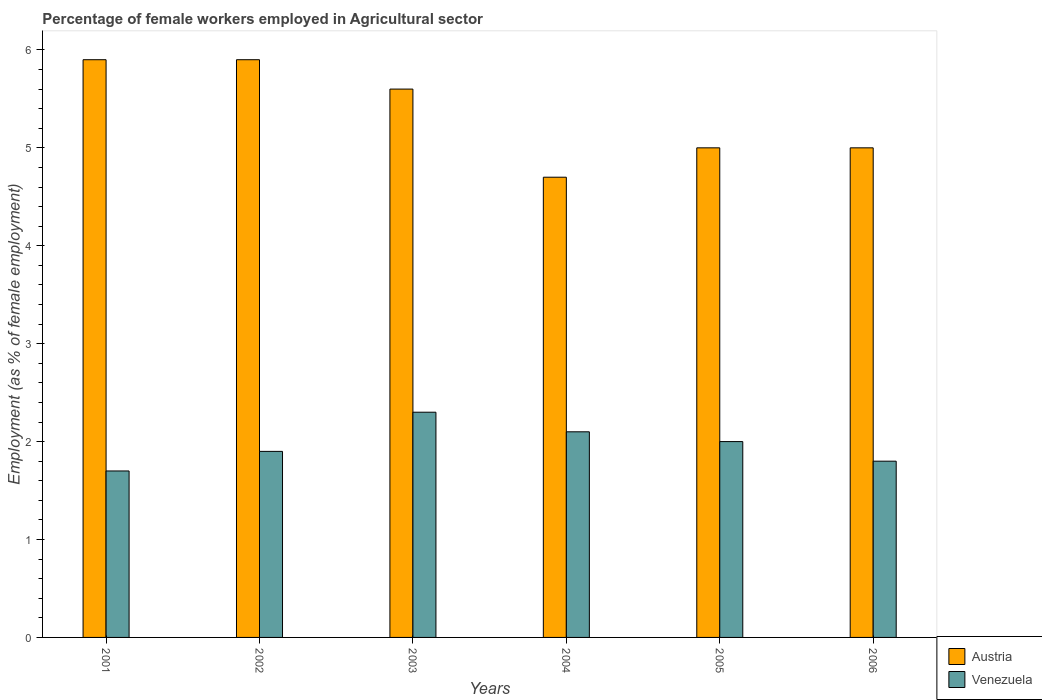How many different coloured bars are there?
Ensure brevity in your answer.  2. Are the number of bars per tick equal to the number of legend labels?
Your response must be concise. Yes. How many bars are there on the 3rd tick from the left?
Your response must be concise. 2. What is the label of the 1st group of bars from the left?
Your answer should be very brief. 2001. In how many cases, is the number of bars for a given year not equal to the number of legend labels?
Your answer should be compact. 0. What is the percentage of females employed in Agricultural sector in Austria in 2005?
Your answer should be very brief. 5. Across all years, what is the maximum percentage of females employed in Agricultural sector in Austria?
Offer a very short reply. 5.9. Across all years, what is the minimum percentage of females employed in Agricultural sector in Austria?
Your response must be concise. 4.7. In which year was the percentage of females employed in Agricultural sector in Austria maximum?
Offer a very short reply. 2001. What is the total percentage of females employed in Agricultural sector in Austria in the graph?
Give a very brief answer. 32.1. What is the difference between the percentage of females employed in Agricultural sector in Venezuela in 2001 and that in 2003?
Give a very brief answer. -0.6. What is the difference between the percentage of females employed in Agricultural sector in Austria in 2003 and the percentage of females employed in Agricultural sector in Venezuela in 2004?
Your answer should be compact. 3.5. What is the average percentage of females employed in Agricultural sector in Austria per year?
Your response must be concise. 5.35. In the year 2005, what is the difference between the percentage of females employed in Agricultural sector in Austria and percentage of females employed in Agricultural sector in Venezuela?
Provide a succinct answer. 3. In how many years, is the percentage of females employed in Agricultural sector in Venezuela greater than 2.2 %?
Offer a terse response. 1. What is the ratio of the percentage of females employed in Agricultural sector in Venezuela in 2004 to that in 2005?
Provide a short and direct response. 1.05. Is the percentage of females employed in Agricultural sector in Austria in 2001 less than that in 2006?
Keep it short and to the point. No. Is the difference between the percentage of females employed in Agricultural sector in Austria in 2005 and 2006 greater than the difference between the percentage of females employed in Agricultural sector in Venezuela in 2005 and 2006?
Provide a short and direct response. No. What is the difference between the highest and the second highest percentage of females employed in Agricultural sector in Austria?
Keep it short and to the point. 0. What is the difference between the highest and the lowest percentage of females employed in Agricultural sector in Austria?
Provide a short and direct response. 1.2. In how many years, is the percentage of females employed in Agricultural sector in Venezuela greater than the average percentage of females employed in Agricultural sector in Venezuela taken over all years?
Your answer should be compact. 3. What does the 1st bar from the left in 2002 represents?
Make the answer very short. Austria. What does the 2nd bar from the right in 2005 represents?
Ensure brevity in your answer.  Austria. Are all the bars in the graph horizontal?
Make the answer very short. No. What is the difference between two consecutive major ticks on the Y-axis?
Your answer should be compact. 1. Are the values on the major ticks of Y-axis written in scientific E-notation?
Provide a short and direct response. No. Does the graph contain any zero values?
Make the answer very short. No. How many legend labels are there?
Ensure brevity in your answer.  2. How are the legend labels stacked?
Your answer should be compact. Vertical. What is the title of the graph?
Your answer should be compact. Percentage of female workers employed in Agricultural sector. Does "Burundi" appear as one of the legend labels in the graph?
Offer a terse response. No. What is the label or title of the X-axis?
Provide a short and direct response. Years. What is the label or title of the Y-axis?
Offer a very short reply. Employment (as % of female employment). What is the Employment (as % of female employment) of Austria in 2001?
Make the answer very short. 5.9. What is the Employment (as % of female employment) of Venezuela in 2001?
Your answer should be very brief. 1.7. What is the Employment (as % of female employment) in Austria in 2002?
Give a very brief answer. 5.9. What is the Employment (as % of female employment) of Venezuela in 2002?
Offer a very short reply. 1.9. What is the Employment (as % of female employment) in Austria in 2003?
Give a very brief answer. 5.6. What is the Employment (as % of female employment) in Venezuela in 2003?
Your response must be concise. 2.3. What is the Employment (as % of female employment) of Austria in 2004?
Provide a short and direct response. 4.7. What is the Employment (as % of female employment) in Venezuela in 2004?
Your answer should be compact. 2.1. What is the Employment (as % of female employment) of Venezuela in 2006?
Provide a succinct answer. 1.8. Across all years, what is the maximum Employment (as % of female employment) of Austria?
Offer a very short reply. 5.9. Across all years, what is the maximum Employment (as % of female employment) in Venezuela?
Provide a short and direct response. 2.3. Across all years, what is the minimum Employment (as % of female employment) in Austria?
Your answer should be very brief. 4.7. Across all years, what is the minimum Employment (as % of female employment) of Venezuela?
Make the answer very short. 1.7. What is the total Employment (as % of female employment) in Austria in the graph?
Keep it short and to the point. 32.1. What is the difference between the Employment (as % of female employment) of Austria in 2001 and that in 2002?
Offer a very short reply. 0. What is the difference between the Employment (as % of female employment) of Venezuela in 2001 and that in 2002?
Ensure brevity in your answer.  -0.2. What is the difference between the Employment (as % of female employment) of Austria in 2001 and that in 2003?
Your answer should be very brief. 0.3. What is the difference between the Employment (as % of female employment) of Austria in 2001 and that in 2006?
Provide a short and direct response. 0.9. What is the difference between the Employment (as % of female employment) of Venezuela in 2001 and that in 2006?
Make the answer very short. -0.1. What is the difference between the Employment (as % of female employment) of Austria in 2002 and that in 2003?
Keep it short and to the point. 0.3. What is the difference between the Employment (as % of female employment) of Venezuela in 2002 and that in 2003?
Your answer should be very brief. -0.4. What is the difference between the Employment (as % of female employment) in Austria in 2002 and that in 2005?
Your answer should be compact. 0.9. What is the difference between the Employment (as % of female employment) in Venezuela in 2002 and that in 2005?
Offer a terse response. -0.1. What is the difference between the Employment (as % of female employment) in Austria in 2003 and that in 2004?
Your answer should be compact. 0.9. What is the difference between the Employment (as % of female employment) in Austria in 2003 and that in 2005?
Give a very brief answer. 0.6. What is the difference between the Employment (as % of female employment) of Venezuela in 2003 and that in 2006?
Offer a very short reply. 0.5. What is the difference between the Employment (as % of female employment) of Austria in 2004 and that in 2005?
Make the answer very short. -0.3. What is the difference between the Employment (as % of female employment) of Venezuela in 2004 and that in 2005?
Your answer should be compact. 0.1. What is the difference between the Employment (as % of female employment) in Austria in 2004 and that in 2006?
Provide a succinct answer. -0.3. What is the difference between the Employment (as % of female employment) of Austria in 2001 and the Employment (as % of female employment) of Venezuela in 2004?
Provide a succinct answer. 3.8. What is the difference between the Employment (as % of female employment) of Austria in 2001 and the Employment (as % of female employment) of Venezuela in 2005?
Provide a short and direct response. 3.9. What is the difference between the Employment (as % of female employment) in Austria in 2001 and the Employment (as % of female employment) in Venezuela in 2006?
Provide a succinct answer. 4.1. What is the difference between the Employment (as % of female employment) in Austria in 2002 and the Employment (as % of female employment) in Venezuela in 2005?
Give a very brief answer. 3.9. What is the difference between the Employment (as % of female employment) of Austria in 2003 and the Employment (as % of female employment) of Venezuela in 2004?
Your response must be concise. 3.5. What is the difference between the Employment (as % of female employment) of Austria in 2003 and the Employment (as % of female employment) of Venezuela in 2005?
Your response must be concise. 3.6. What is the difference between the Employment (as % of female employment) in Austria in 2004 and the Employment (as % of female employment) in Venezuela in 2005?
Offer a very short reply. 2.7. What is the difference between the Employment (as % of female employment) of Austria in 2005 and the Employment (as % of female employment) of Venezuela in 2006?
Offer a terse response. 3.2. What is the average Employment (as % of female employment) of Austria per year?
Provide a succinct answer. 5.35. What is the average Employment (as % of female employment) of Venezuela per year?
Keep it short and to the point. 1.97. In the year 2003, what is the difference between the Employment (as % of female employment) in Austria and Employment (as % of female employment) in Venezuela?
Provide a succinct answer. 3.3. In the year 2005, what is the difference between the Employment (as % of female employment) in Austria and Employment (as % of female employment) in Venezuela?
Keep it short and to the point. 3. In the year 2006, what is the difference between the Employment (as % of female employment) of Austria and Employment (as % of female employment) of Venezuela?
Keep it short and to the point. 3.2. What is the ratio of the Employment (as % of female employment) of Austria in 2001 to that in 2002?
Your answer should be very brief. 1. What is the ratio of the Employment (as % of female employment) in Venezuela in 2001 to that in 2002?
Your answer should be compact. 0.89. What is the ratio of the Employment (as % of female employment) in Austria in 2001 to that in 2003?
Provide a succinct answer. 1.05. What is the ratio of the Employment (as % of female employment) in Venezuela in 2001 to that in 2003?
Offer a terse response. 0.74. What is the ratio of the Employment (as % of female employment) in Austria in 2001 to that in 2004?
Provide a short and direct response. 1.26. What is the ratio of the Employment (as % of female employment) of Venezuela in 2001 to that in 2004?
Provide a succinct answer. 0.81. What is the ratio of the Employment (as % of female employment) of Austria in 2001 to that in 2005?
Ensure brevity in your answer.  1.18. What is the ratio of the Employment (as % of female employment) in Austria in 2001 to that in 2006?
Make the answer very short. 1.18. What is the ratio of the Employment (as % of female employment) of Austria in 2002 to that in 2003?
Provide a succinct answer. 1.05. What is the ratio of the Employment (as % of female employment) in Venezuela in 2002 to that in 2003?
Provide a succinct answer. 0.83. What is the ratio of the Employment (as % of female employment) in Austria in 2002 to that in 2004?
Make the answer very short. 1.26. What is the ratio of the Employment (as % of female employment) of Venezuela in 2002 to that in 2004?
Offer a very short reply. 0.9. What is the ratio of the Employment (as % of female employment) of Austria in 2002 to that in 2005?
Provide a succinct answer. 1.18. What is the ratio of the Employment (as % of female employment) in Venezuela in 2002 to that in 2005?
Your answer should be compact. 0.95. What is the ratio of the Employment (as % of female employment) of Austria in 2002 to that in 2006?
Offer a very short reply. 1.18. What is the ratio of the Employment (as % of female employment) in Venezuela in 2002 to that in 2006?
Offer a terse response. 1.06. What is the ratio of the Employment (as % of female employment) of Austria in 2003 to that in 2004?
Provide a short and direct response. 1.19. What is the ratio of the Employment (as % of female employment) of Venezuela in 2003 to that in 2004?
Offer a terse response. 1.1. What is the ratio of the Employment (as % of female employment) in Austria in 2003 to that in 2005?
Offer a terse response. 1.12. What is the ratio of the Employment (as % of female employment) of Venezuela in 2003 to that in 2005?
Ensure brevity in your answer.  1.15. What is the ratio of the Employment (as % of female employment) in Austria in 2003 to that in 2006?
Your answer should be very brief. 1.12. What is the ratio of the Employment (as % of female employment) in Venezuela in 2003 to that in 2006?
Offer a terse response. 1.28. What is the ratio of the Employment (as % of female employment) of Austria in 2004 to that in 2005?
Your answer should be very brief. 0.94. What is the ratio of the Employment (as % of female employment) of Venezuela in 2004 to that in 2006?
Your answer should be very brief. 1.17. What is the ratio of the Employment (as % of female employment) of Venezuela in 2005 to that in 2006?
Your response must be concise. 1.11. What is the difference between the highest and the second highest Employment (as % of female employment) in Venezuela?
Keep it short and to the point. 0.2. What is the difference between the highest and the lowest Employment (as % of female employment) in Austria?
Give a very brief answer. 1.2. 